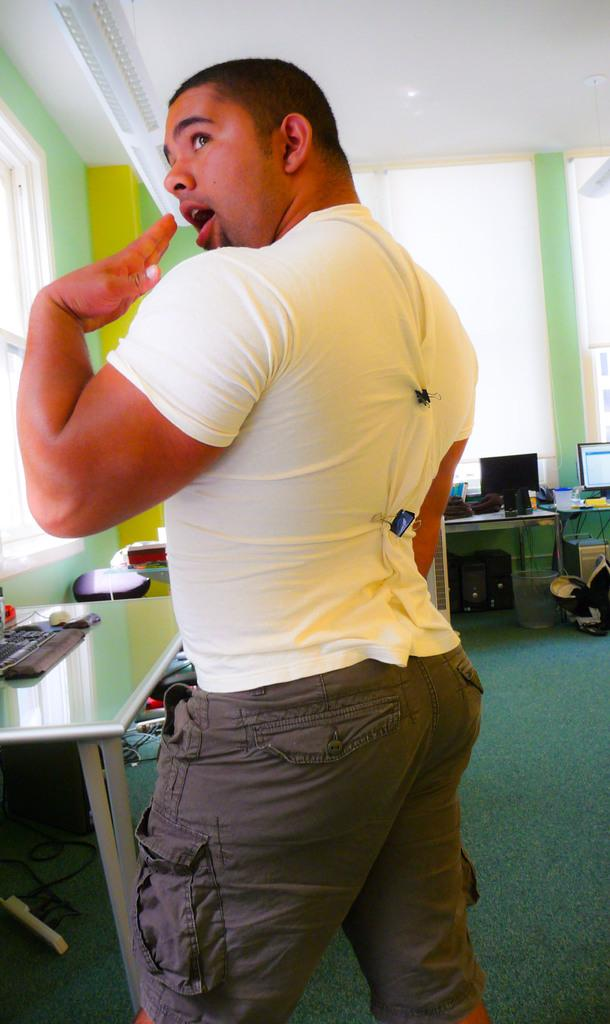What is the main subject of the image? There is a person standing in the image. What can be seen in the background of the image? There is a table, a monitor, a wall, a window, and the ceiling visible in the background of the image. Can you describe the table in the background? The table has a monitor on it. What type of addition problem can be solved using the person's skin in the image? There is no addition problem or reference to the person's skin in the image, so it cannot be used to solve any mathematical problems. 